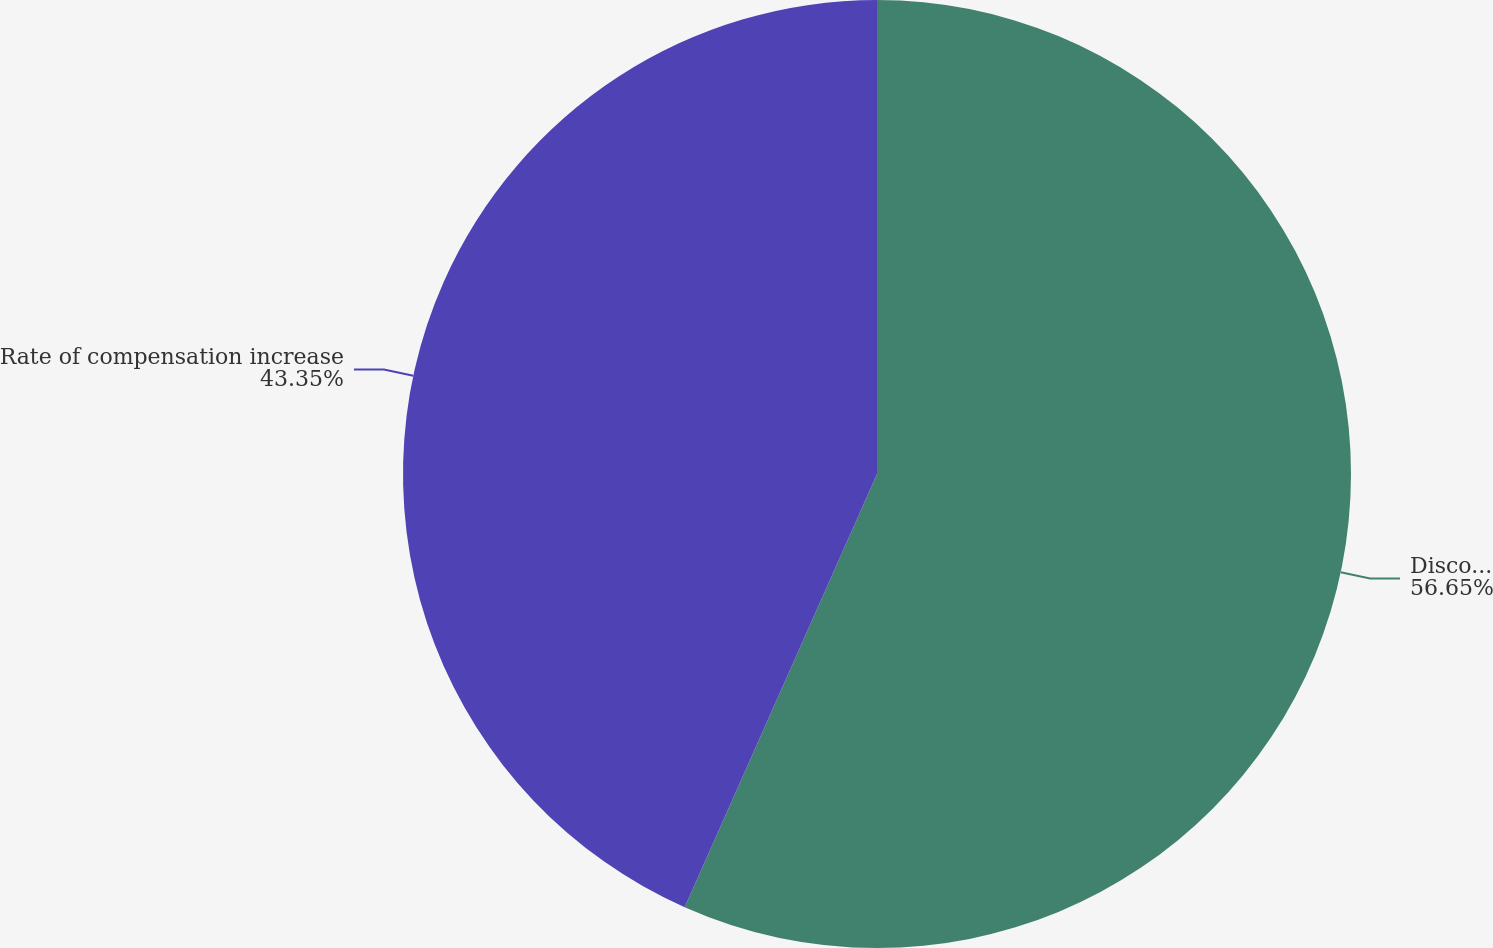<chart> <loc_0><loc_0><loc_500><loc_500><pie_chart><fcel>Discount rate<fcel>Rate of compensation increase<nl><fcel>56.65%<fcel>43.35%<nl></chart> 